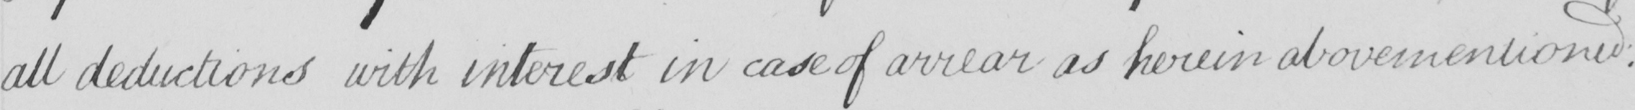What does this handwritten line say? all deductions with interest in case of arrear as herein abovementioned . 